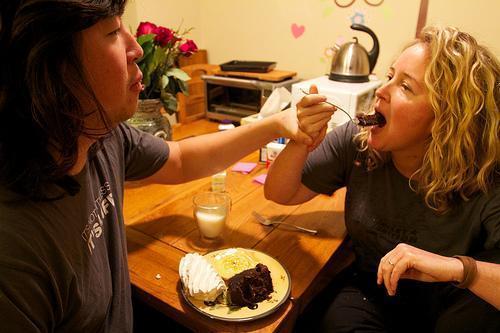How many forks are on the table?
Give a very brief answer. 1. 